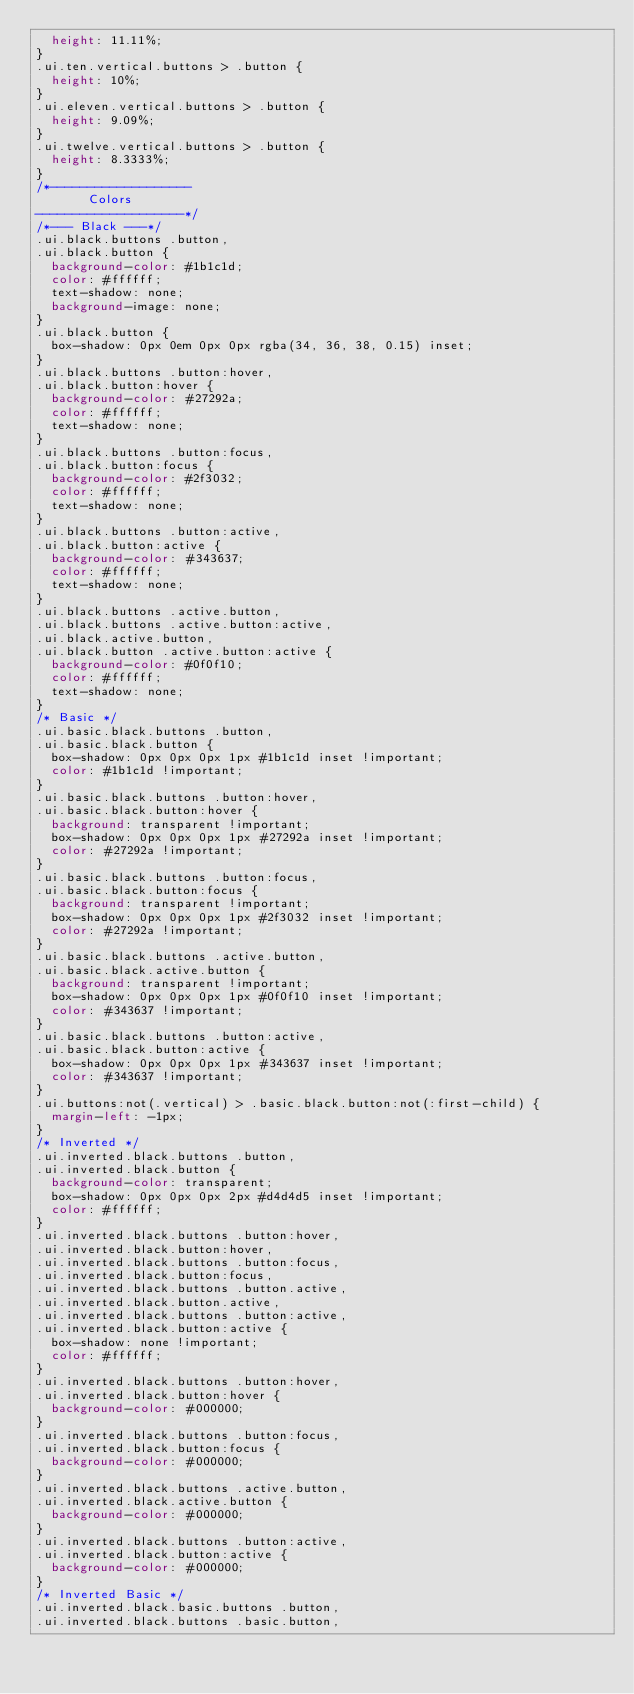<code> <loc_0><loc_0><loc_500><loc_500><_CSS_>  height: 11.11%;
}
.ui.ten.vertical.buttons > .button {
  height: 10%;
}
.ui.eleven.vertical.buttons > .button {
  height: 9.09%;
}
.ui.twelve.vertical.buttons > .button {
  height: 8.3333%;
}
/*-------------------
       Colors
--------------------*/
/*--- Black ---*/
.ui.black.buttons .button,
.ui.black.button {
  background-color: #1b1c1d;
  color: #ffffff;
  text-shadow: none;
  background-image: none;
}
.ui.black.button {
  box-shadow: 0px 0em 0px 0px rgba(34, 36, 38, 0.15) inset;
}
.ui.black.buttons .button:hover,
.ui.black.button:hover {
  background-color: #27292a;
  color: #ffffff;
  text-shadow: none;
}
.ui.black.buttons .button:focus,
.ui.black.button:focus {
  background-color: #2f3032;
  color: #ffffff;
  text-shadow: none;
}
.ui.black.buttons .button:active,
.ui.black.button:active {
  background-color: #343637;
  color: #ffffff;
  text-shadow: none;
}
.ui.black.buttons .active.button,
.ui.black.buttons .active.button:active,
.ui.black.active.button,
.ui.black.button .active.button:active {
  background-color: #0f0f10;
  color: #ffffff;
  text-shadow: none;
}
/* Basic */
.ui.basic.black.buttons .button,
.ui.basic.black.button {
  box-shadow: 0px 0px 0px 1px #1b1c1d inset !important;
  color: #1b1c1d !important;
}
.ui.basic.black.buttons .button:hover,
.ui.basic.black.button:hover {
  background: transparent !important;
  box-shadow: 0px 0px 0px 1px #27292a inset !important;
  color: #27292a !important;
}
.ui.basic.black.buttons .button:focus,
.ui.basic.black.button:focus {
  background: transparent !important;
  box-shadow: 0px 0px 0px 1px #2f3032 inset !important;
  color: #27292a !important;
}
.ui.basic.black.buttons .active.button,
.ui.basic.black.active.button {
  background: transparent !important;
  box-shadow: 0px 0px 0px 1px #0f0f10 inset !important;
  color: #343637 !important;
}
.ui.basic.black.buttons .button:active,
.ui.basic.black.button:active {
  box-shadow: 0px 0px 0px 1px #343637 inset !important;
  color: #343637 !important;
}
.ui.buttons:not(.vertical) > .basic.black.button:not(:first-child) {
  margin-left: -1px;
}
/* Inverted */
.ui.inverted.black.buttons .button,
.ui.inverted.black.button {
  background-color: transparent;
  box-shadow: 0px 0px 0px 2px #d4d4d5 inset !important;
  color: #ffffff;
}
.ui.inverted.black.buttons .button:hover,
.ui.inverted.black.button:hover,
.ui.inverted.black.buttons .button:focus,
.ui.inverted.black.button:focus,
.ui.inverted.black.buttons .button.active,
.ui.inverted.black.button.active,
.ui.inverted.black.buttons .button:active,
.ui.inverted.black.button:active {
  box-shadow: none !important;
  color: #ffffff;
}
.ui.inverted.black.buttons .button:hover,
.ui.inverted.black.button:hover {
  background-color: #000000;
}
.ui.inverted.black.buttons .button:focus,
.ui.inverted.black.button:focus {
  background-color: #000000;
}
.ui.inverted.black.buttons .active.button,
.ui.inverted.black.active.button {
  background-color: #000000;
}
.ui.inverted.black.buttons .button:active,
.ui.inverted.black.button:active {
  background-color: #000000;
}
/* Inverted Basic */
.ui.inverted.black.basic.buttons .button,
.ui.inverted.black.buttons .basic.button,</code> 